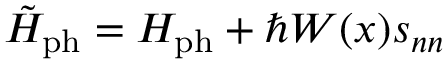Convert formula to latex. <formula><loc_0><loc_0><loc_500><loc_500>\tilde { H } _ { p h } = H _ { p h } + \hbar { W } ( x ) s _ { n n }</formula> 